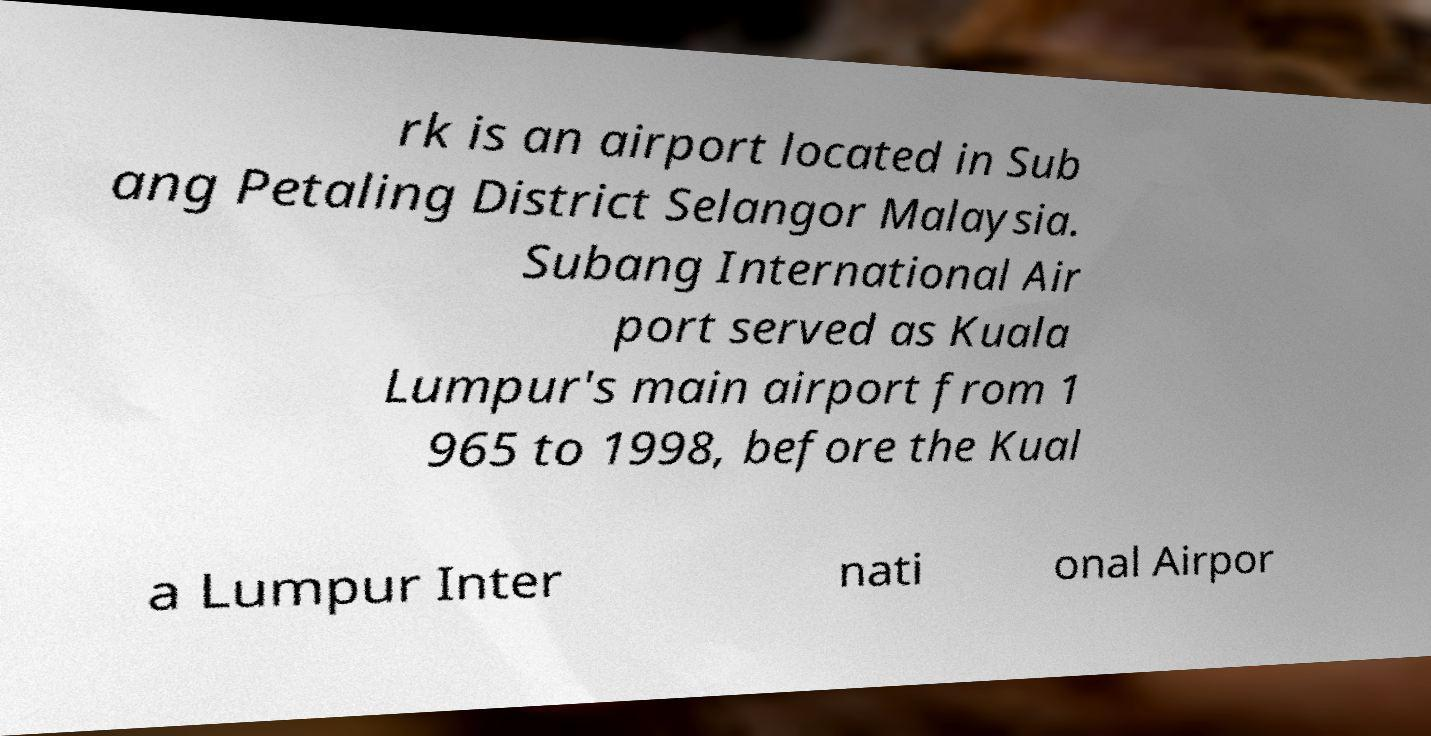Please identify and transcribe the text found in this image. rk is an airport located in Sub ang Petaling District Selangor Malaysia. Subang International Air port served as Kuala Lumpur's main airport from 1 965 to 1998, before the Kual a Lumpur Inter nati onal Airpor 